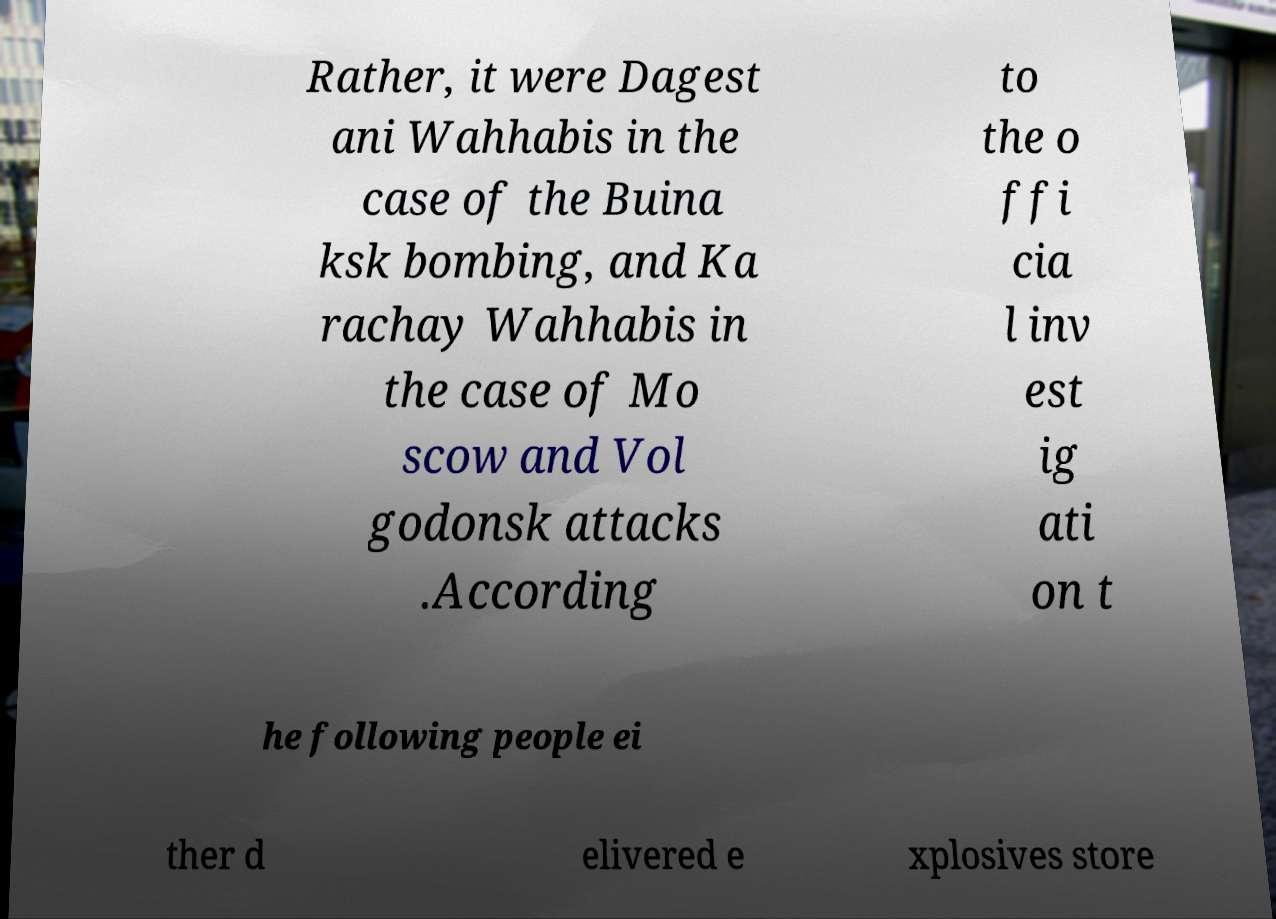What messages or text are displayed in this image? I need them in a readable, typed format. Rather, it were Dagest ani Wahhabis in the case of the Buina ksk bombing, and Ka rachay Wahhabis in the case of Mo scow and Vol godonsk attacks .According to the o ffi cia l inv est ig ati on t he following people ei ther d elivered e xplosives store 